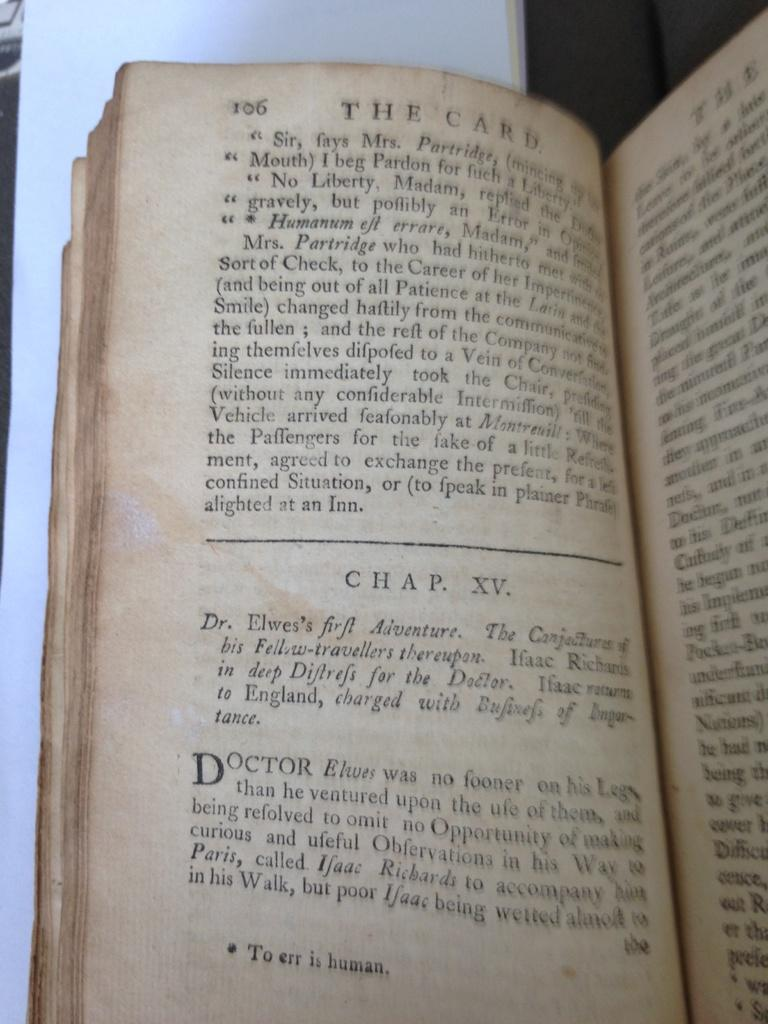Provide a one-sentence caption for the provided image. An old book entitled The Card is open to chapter fifteen. 